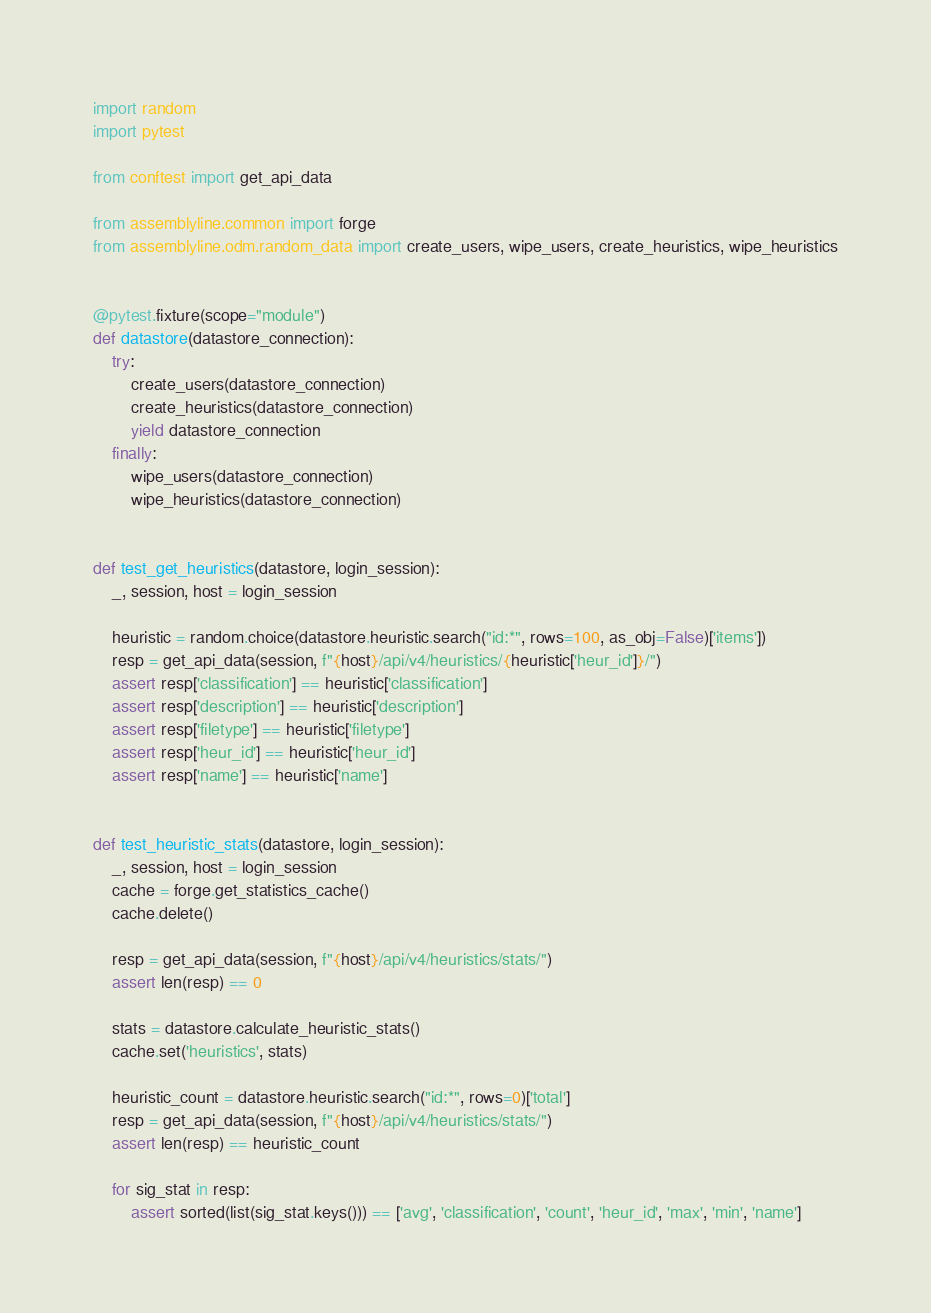Convert code to text. <code><loc_0><loc_0><loc_500><loc_500><_Python_>
import random
import pytest

from conftest import get_api_data

from assemblyline.common import forge
from assemblyline.odm.random_data import create_users, wipe_users, create_heuristics, wipe_heuristics


@pytest.fixture(scope="module")
def datastore(datastore_connection):
    try:
        create_users(datastore_connection)
        create_heuristics(datastore_connection)
        yield datastore_connection
    finally:
        wipe_users(datastore_connection)
        wipe_heuristics(datastore_connection)


def test_get_heuristics(datastore, login_session):
    _, session, host = login_session

    heuristic = random.choice(datastore.heuristic.search("id:*", rows=100, as_obj=False)['items'])
    resp = get_api_data(session, f"{host}/api/v4/heuristics/{heuristic['heur_id']}/")
    assert resp['classification'] == heuristic['classification']
    assert resp['description'] == heuristic['description']
    assert resp['filetype'] == heuristic['filetype']
    assert resp['heur_id'] == heuristic['heur_id']
    assert resp['name'] == heuristic['name']


def test_heuristic_stats(datastore, login_session):
    _, session, host = login_session
    cache = forge.get_statistics_cache()
    cache.delete()

    resp = get_api_data(session, f"{host}/api/v4/heuristics/stats/")
    assert len(resp) == 0

    stats = datastore.calculate_heuristic_stats()
    cache.set('heuristics', stats)

    heuristic_count = datastore.heuristic.search("id:*", rows=0)['total']
    resp = get_api_data(session, f"{host}/api/v4/heuristics/stats/")
    assert len(resp) == heuristic_count

    for sig_stat in resp:
        assert sorted(list(sig_stat.keys())) == ['avg', 'classification', 'count', 'heur_id', 'max', 'min', 'name']
</code> 